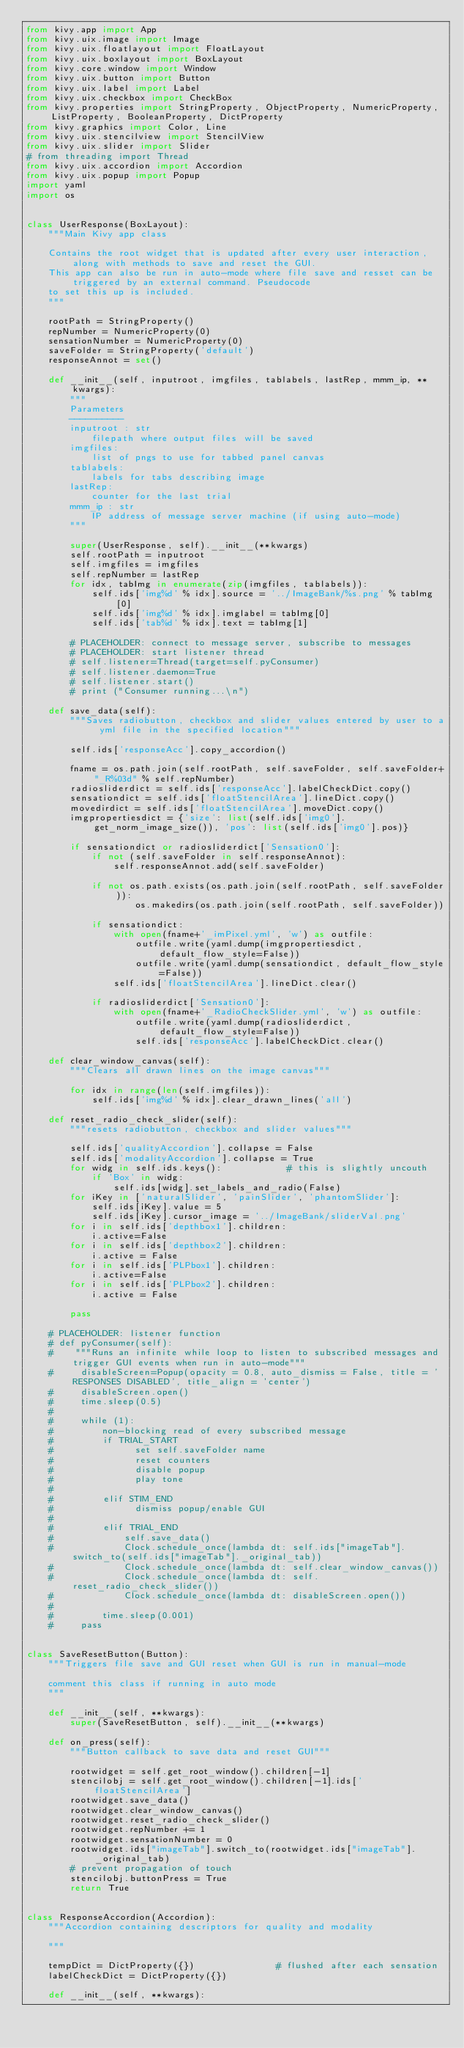Convert code to text. <code><loc_0><loc_0><loc_500><loc_500><_Python_>from kivy.app import App
from kivy.uix.image import Image
from kivy.uix.floatlayout import FloatLayout
from kivy.uix.boxlayout import BoxLayout
from kivy.core.window import Window
from kivy.uix.button import Button
from kivy.uix.label import Label
from kivy.uix.checkbox import CheckBox
from kivy.properties import StringProperty, ObjectProperty, NumericProperty, ListProperty, BooleanProperty, DictProperty
from kivy.graphics import Color, Line
from kivy.uix.stencilview import StencilView
from kivy.uix.slider import Slider
# from threading import Thread
from kivy.uix.accordion import Accordion
from kivy.uix.popup import Popup
import yaml
import os


class UserResponse(BoxLayout):
    """Main Kivy app class

    Contains the root widget that is updated after every user interaction, along with methods to save and reset the GUI.
    This app can also be run in auto-mode where file save and resset can be triggered by an external command. Pseudocode
    to set this up is included.
    """

    rootPath = StringProperty()
    repNumber = NumericProperty(0)
    sensationNumber = NumericProperty(0)
    saveFolder = StringProperty('default')
    responseAnnot = set()

    def __init__(self, inputroot, imgfiles, tablabels, lastRep, mmm_ip, **kwargs):
        """
        Parameters
        ----------
        inputroot : str
            filepath where output files will be saved
        imgfiles:
            list of pngs to use for tabbed panel canvas
        tablabels:
            labels for tabs describing image
        lastRep:
            counter for the last trial
        mmm_ip : str
            IP address of message server machine (if using auto-mode)
        """

        super(UserResponse, self).__init__(**kwargs)
        self.rootPath = inputroot
        self.imgfiles = imgfiles
        self.repNumber = lastRep
        for idx, tabImg in enumerate(zip(imgfiles, tablabels)):
            self.ids['img%d' % idx].source = '../ImageBank/%s.png' % tabImg[0]
            self.ids['img%d' % idx].imglabel = tabImg[0]
            self.ids['tab%d' % idx].text = tabImg[1]

        # PLACEHOLDER: connect to message server, subscribe to messages
        # PLACEHOLDER: start listener thread
        # self.listener=Thread(target=self.pyConsumer)
        # self.listener.daemon=True
        # self.listener.start()
        # print ("Consumer running...\n")

    def save_data(self):
        """Saves radiobutton, checkbox and slider values entered by user to a yml file in the specified location"""

        self.ids['responseAcc'].copy_accordion()

        fname = os.path.join(self.rootPath, self.saveFolder, self.saveFolder+"_R%03d" % self.repNumber)
        radiosliderdict = self.ids['responseAcc'].labelCheckDict.copy()
        sensationdict = self.ids['floatStencilArea'].lineDict.copy()
        movedirdict = self.ids['floatStencilArea'].moveDict.copy()
        imgpropertiesdict = {'size': list(self.ids['img0'].get_norm_image_size()), 'pos': list(self.ids['img0'].pos)}

        if sensationdict or radiosliderdict['Sensation0']:
            if not (self.saveFolder in self.responseAnnot):
                self.responseAnnot.add(self.saveFolder)

            if not os.path.exists(os.path.join(self.rootPath, self.saveFolder)):
                    os.makedirs(os.path.join(self.rootPath, self.saveFolder))

            if sensationdict:
                with open(fname+'_imPixel.yml', 'w') as outfile:
                    outfile.write(yaml.dump(imgpropertiesdict, default_flow_style=False))
                    outfile.write(yaml.dump(sensationdict, default_flow_style=False))
                self.ids['floatStencilArea'].lineDict.clear()

            if radiosliderdict['Sensation0']:
                with open(fname+'_RadioCheckSlider.yml', 'w') as outfile:
                    outfile.write(yaml.dump(radiosliderdict, default_flow_style=False))
                    self.ids['responseAcc'].labelCheckDict.clear()

    def clear_window_canvas(self):
        """Clears all drawn lines on the image canvas"""

        for idx in range(len(self.imgfiles)):
            self.ids['img%d' % idx].clear_drawn_lines('all')

    def reset_radio_check_slider(self):
        """resets radiobutton, checkbox and slider values"""

        self.ids['qualityAccordion'].collapse = False
        self.ids['modalityAccordion'].collapse = True
        for widg in self.ids.keys():            # this is slightly uncouth
            if 'Box' in widg:
                self.ids[widg].set_labels_and_radio(False)
        for iKey in ['naturalSlider', 'painSlider', 'phantomSlider']:
            self.ids[iKey].value = 5
            self.ids[iKey].cursor_image = '../ImageBank/sliderVal.png'
        for i in self.ids['depthbox1'].children:
            i.active=False
        for i in self.ids['depthbox2'].children:
            i.active = False
        for i in self.ids['PLPbox1'].children:
            i.active=False
        for i in self.ids['PLPbox2'].children:
            i.active = False

        pass

    # PLACEHOLDER: listener function
    # def pyConsumer(self):
    #    """Runs an infinite while loop to listen to subscribed messages and trigger GUI events when run in auto-mode"""
    #     disableScreen=Popup(opacity = 0.8, auto_dismiss = False, title = 'RESPONSES DISABLED', title_align = 'center')
    #     disableScreen.open()
    #     time.sleep(0.5)
    #
    #     while (1):
    #         non-blocking read of every subscribed message
    #         if TRIAL_START
    #               set self.saveFolder name
    #               reset counters
    #               disable popup
    #               play tone
    #
    #         elif STIM_END
    #               dismiss popup/enable GUI
    #
    #         elif TRIAL_END
    #             self.save_data()
    #             Clock.schedule_once(lambda dt: self.ids["imageTab"].switch_to(self.ids["imageTab"]._original_tab))
    #             Clock.schedule_once(lambda dt: self.clear_window_canvas())
    #             Clock.schedule_once(lambda dt: self.reset_radio_check_slider())
    #             Clock.schedule_once(lambda dt: disableScreen.open())
    #
    #         time.sleep(0.001)
    #     pass


class SaveResetButton(Button):
    """Triggers file save and GUI reset when GUI is run in manual-mode

    comment this class if running in auto mode
    """

    def __init__(self, **kwargs):
        super(SaveResetButton, self).__init__(**kwargs)

    def on_press(self):
        """Button callback to save data and reset GUI"""

        rootwidget = self.get_root_window().children[-1]
        stencilobj = self.get_root_window().children[-1].ids['floatStencilArea']
        rootwidget.save_data()
        rootwidget.clear_window_canvas()
        rootwidget.reset_radio_check_slider()
        rootwidget.repNumber += 1
        rootwidget.sensationNumber = 0
        rootwidget.ids["imageTab"].switch_to(rootwidget.ids["imageTab"]._original_tab)
        # prevent propagation of touch
        stencilobj.buttonPress = True
        return True


class ResponseAccordion(Accordion):
    """Accordion containing descriptors for quality and modality

    """

    tempDict = DictProperty({})               # flushed after each sensation
    labelCheckDict = DictProperty({})

    def __init__(self, **kwargs):</code> 